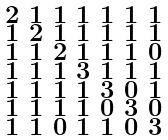<formula> <loc_0><loc_0><loc_500><loc_500>\begin{smallmatrix} 2 & 1 & 1 & 1 & 1 & 1 & 1 \\ 1 & 2 & 1 & 1 & 1 & 1 & 1 \\ 1 & 1 & 2 & 1 & 1 & 1 & 0 \\ 1 & 1 & 1 & 3 & 1 & 1 & 1 \\ 1 & 1 & 1 & 1 & 3 & 0 & 1 \\ 1 & 1 & 1 & 1 & 0 & 3 & 0 \\ 1 & 1 & 0 & 1 & 1 & 0 & 3 \end{smallmatrix}</formula> 